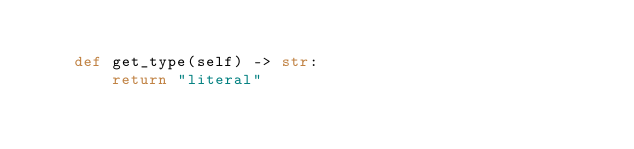<code> <loc_0><loc_0><loc_500><loc_500><_Python_>
    def get_type(self) -> str:
        return "literal"</code> 